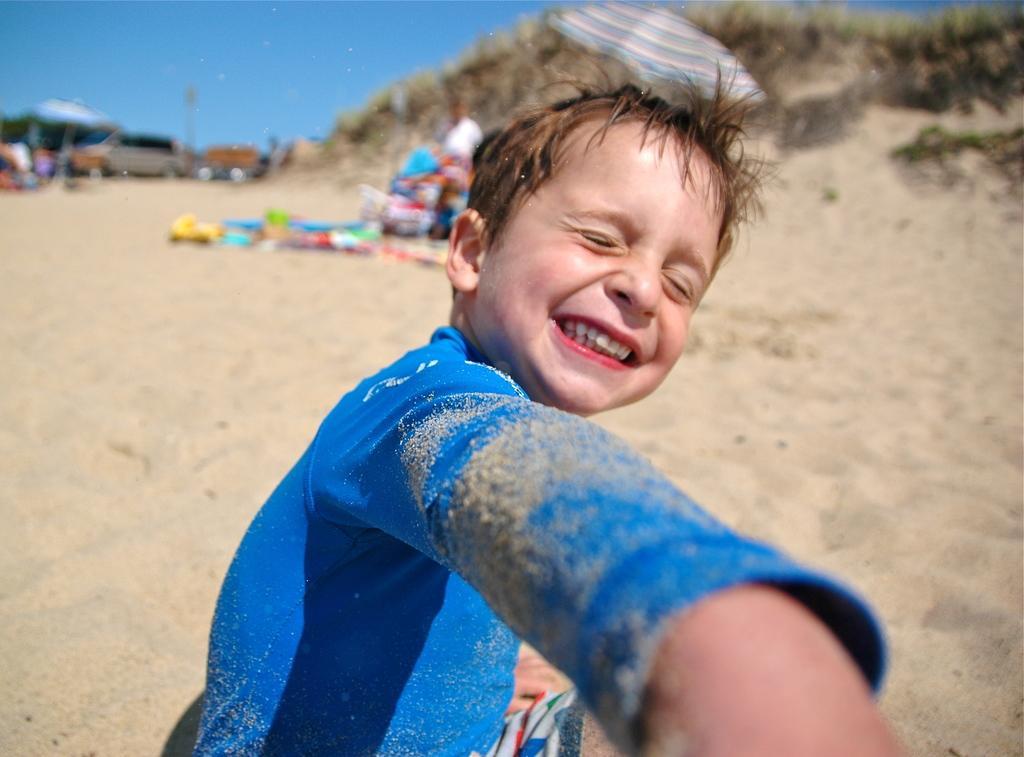Could you give a brief overview of what you see in this image? There is a boy sitting on sand. On the background we can see persons,umbrella,grass,vehicles and sky. 